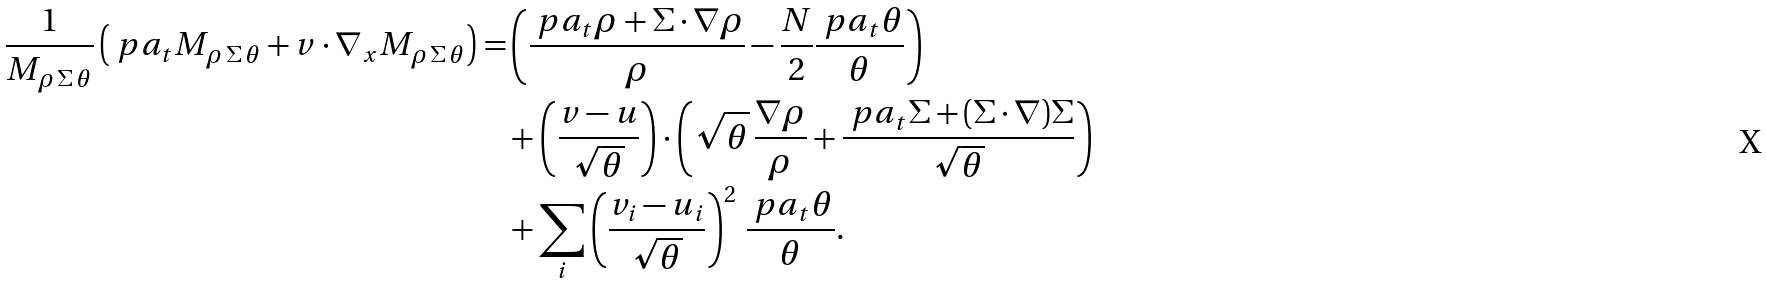Convert formula to latex. <formula><loc_0><loc_0><loc_500><loc_500>\frac { 1 } { M _ { \rho \, \Sigma \, \theta } } \left ( \ p a _ { t } M _ { \rho \, \Sigma \, \theta } + v \cdot \nabla _ { x } M _ { \rho \, \Sigma \, \theta } \right ) = & \left ( \frac { \ p a _ { t } \rho + \Sigma \cdot \nabla \rho } { \rho } - \frac { N } { 2 } \frac { \ p a _ { t } \theta } { \theta } \right ) \\ & + \left ( \frac { v - u } { \sqrt { \theta } } \right ) \cdot \left ( \sqrt { \theta } \, \frac { \nabla \rho } { \rho } + \frac { \ p a _ { t } \Sigma + ( \Sigma \cdot \nabla ) \Sigma } { \sqrt { \theta } } \right ) \\ & + \sum _ { i } \left ( \frac { v _ { i } - u _ { i } } { \sqrt { \theta } } \right ) ^ { 2 } \, \frac { \ p a _ { t } \theta } { \theta } .</formula> 